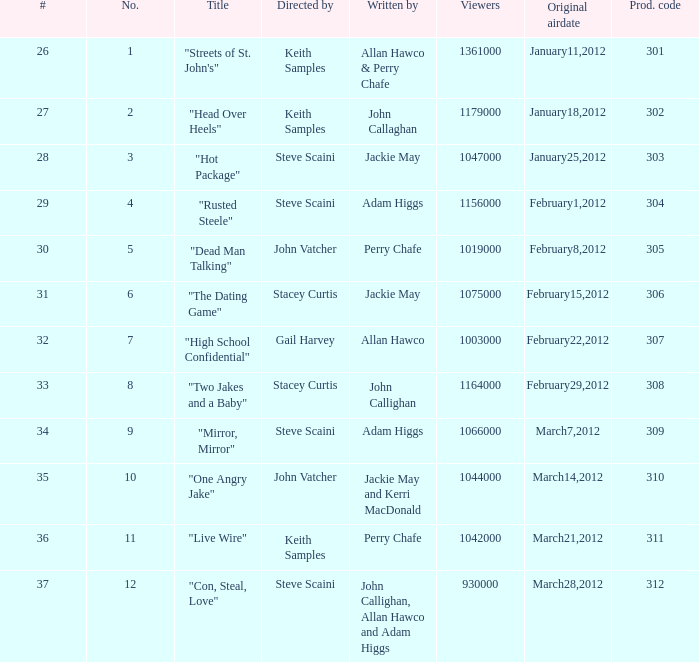What is the aggregate quantity of films helmed and scripted by john callaghan? 1.0. 